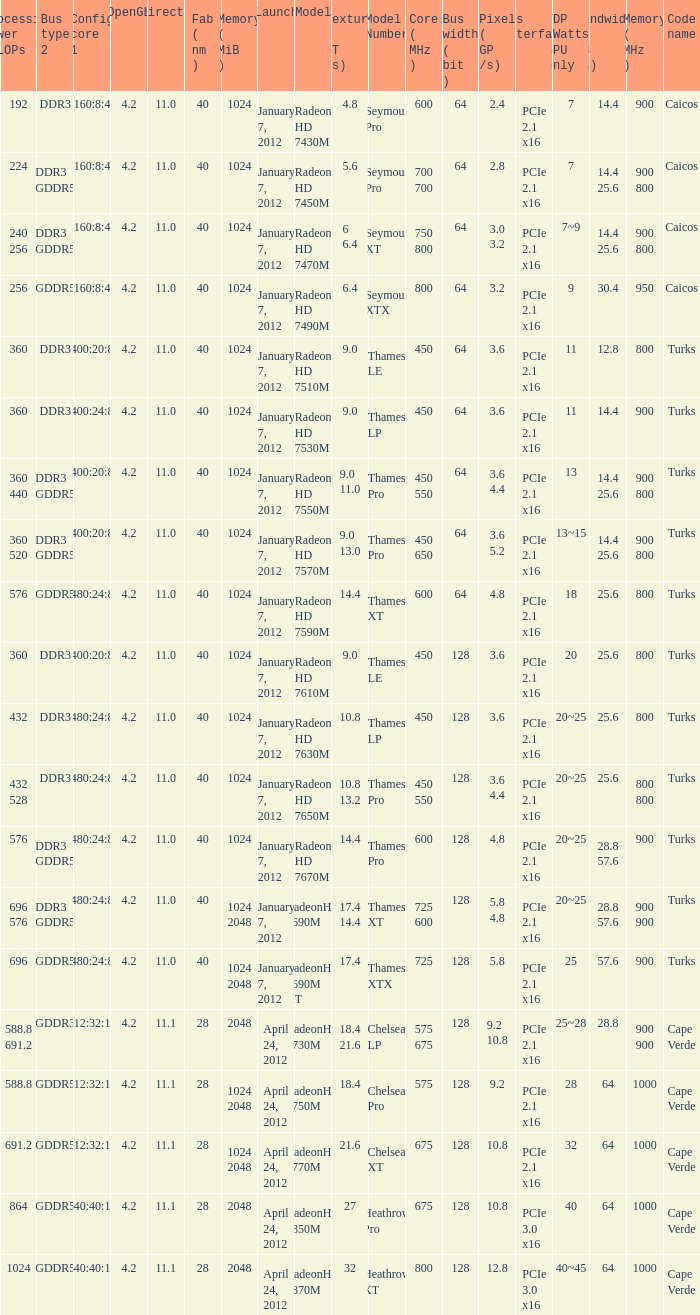How many texture (gt/s) the card has if the tdp (watts) GPU only is 18? 1.0. 